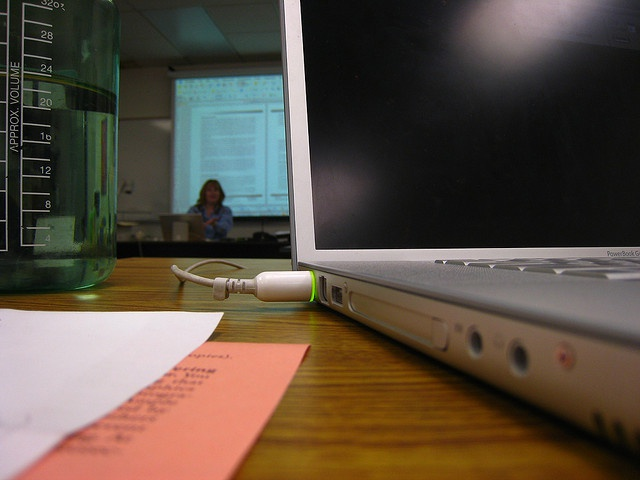Describe the objects in this image and their specific colors. I can see laptop in black, gray, and maroon tones, tv in black, gray, darkgray, and lightgray tones, bottle in black, darkgreen, and gray tones, tv in black, teal, lightblue, and gray tones, and keyboard in black, gray, and darkgray tones in this image. 